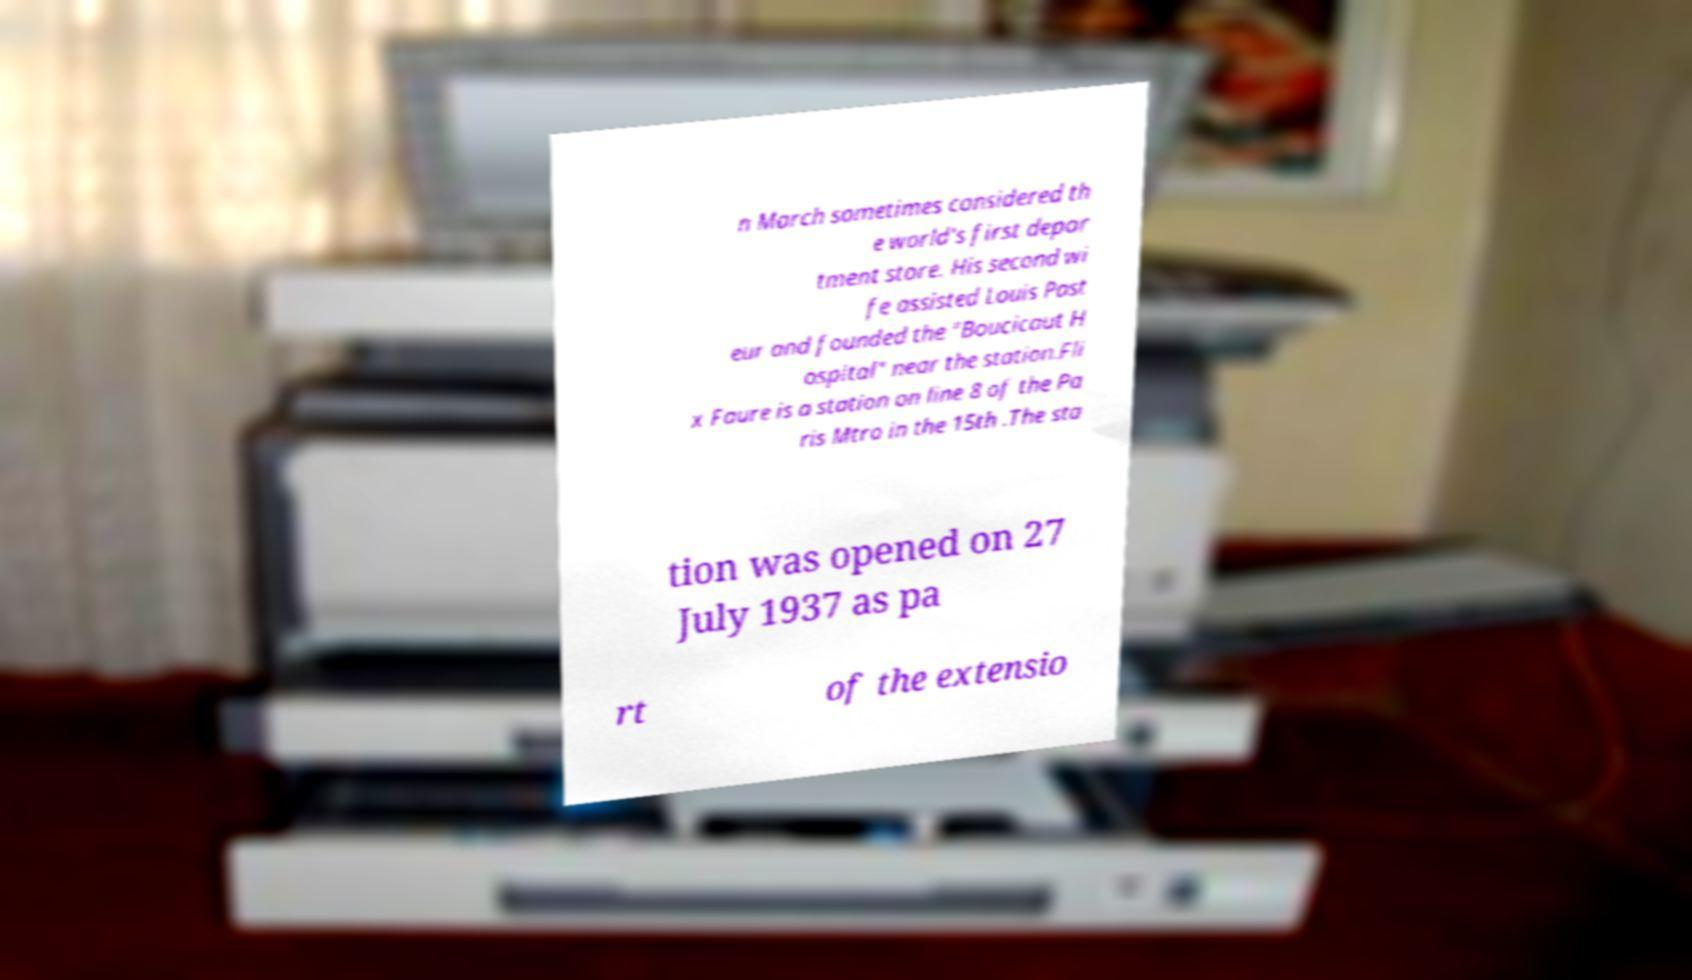There's text embedded in this image that I need extracted. Can you transcribe it verbatim? n March sometimes considered th e world's first depar tment store. His second wi fe assisted Louis Past eur and founded the "Boucicaut H ospital" near the station.Fli x Faure is a station on line 8 of the Pa ris Mtro in the 15th .The sta tion was opened on 27 July 1937 as pa rt of the extensio 